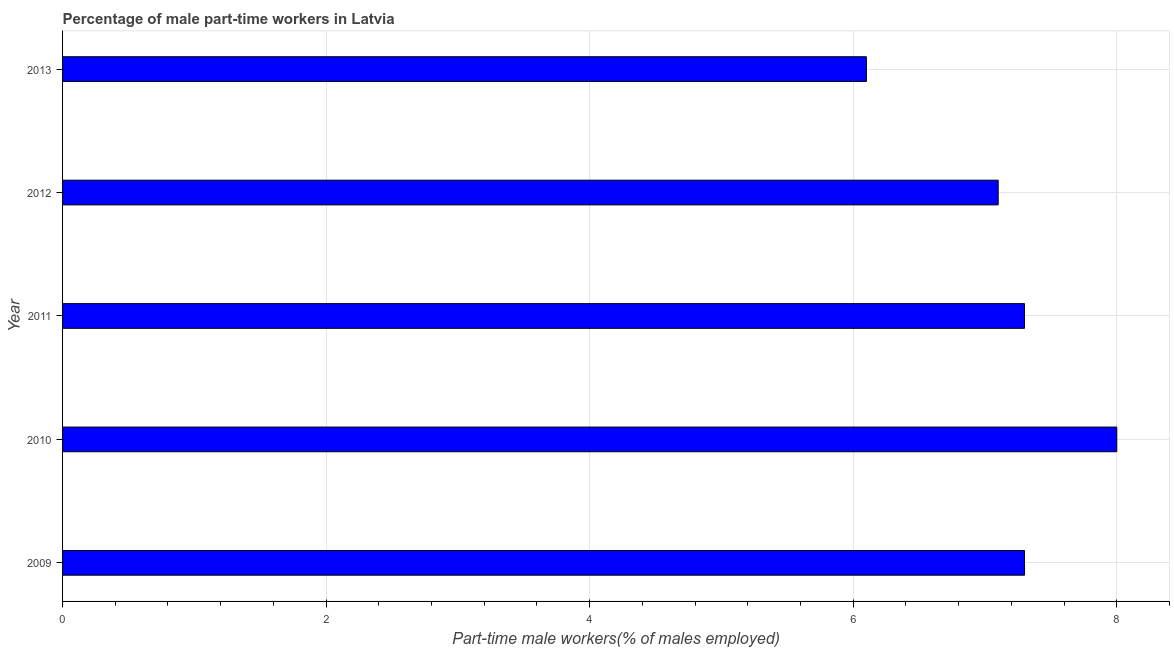What is the title of the graph?
Provide a short and direct response. Percentage of male part-time workers in Latvia. What is the label or title of the X-axis?
Your answer should be compact. Part-time male workers(% of males employed). What is the percentage of part-time male workers in 2012?
Offer a terse response. 7.1. Across all years, what is the minimum percentage of part-time male workers?
Offer a very short reply. 6.1. In which year was the percentage of part-time male workers maximum?
Your response must be concise. 2010. What is the sum of the percentage of part-time male workers?
Give a very brief answer. 35.8. What is the difference between the percentage of part-time male workers in 2009 and 2012?
Offer a very short reply. 0.2. What is the average percentage of part-time male workers per year?
Your response must be concise. 7.16. What is the median percentage of part-time male workers?
Offer a very short reply. 7.3. In how many years, is the percentage of part-time male workers greater than 6 %?
Provide a succinct answer. 5. Do a majority of the years between 2010 and 2012 (inclusive) have percentage of part-time male workers greater than 7.6 %?
Your answer should be very brief. No. Is the percentage of part-time male workers in 2009 less than that in 2013?
Provide a succinct answer. No. Is the sum of the percentage of part-time male workers in 2009 and 2013 greater than the maximum percentage of part-time male workers across all years?
Your response must be concise. Yes. What is the difference between the highest and the lowest percentage of part-time male workers?
Give a very brief answer. 1.9. Are all the bars in the graph horizontal?
Your response must be concise. Yes. What is the difference between two consecutive major ticks on the X-axis?
Give a very brief answer. 2. Are the values on the major ticks of X-axis written in scientific E-notation?
Offer a very short reply. No. What is the Part-time male workers(% of males employed) of 2009?
Make the answer very short. 7.3. What is the Part-time male workers(% of males employed) of 2010?
Offer a very short reply. 8. What is the Part-time male workers(% of males employed) of 2011?
Offer a very short reply. 7.3. What is the Part-time male workers(% of males employed) of 2012?
Make the answer very short. 7.1. What is the Part-time male workers(% of males employed) of 2013?
Your answer should be very brief. 6.1. What is the difference between the Part-time male workers(% of males employed) in 2009 and 2011?
Give a very brief answer. 0. What is the difference between the Part-time male workers(% of males employed) in 2010 and 2011?
Your answer should be very brief. 0.7. What is the difference between the Part-time male workers(% of males employed) in 2010 and 2012?
Keep it short and to the point. 0.9. What is the difference between the Part-time male workers(% of males employed) in 2011 and 2013?
Your answer should be compact. 1.2. What is the difference between the Part-time male workers(% of males employed) in 2012 and 2013?
Provide a short and direct response. 1. What is the ratio of the Part-time male workers(% of males employed) in 2009 to that in 2012?
Make the answer very short. 1.03. What is the ratio of the Part-time male workers(% of males employed) in 2009 to that in 2013?
Provide a succinct answer. 1.2. What is the ratio of the Part-time male workers(% of males employed) in 2010 to that in 2011?
Keep it short and to the point. 1.1. What is the ratio of the Part-time male workers(% of males employed) in 2010 to that in 2012?
Provide a succinct answer. 1.13. What is the ratio of the Part-time male workers(% of males employed) in 2010 to that in 2013?
Give a very brief answer. 1.31. What is the ratio of the Part-time male workers(% of males employed) in 2011 to that in 2012?
Keep it short and to the point. 1.03. What is the ratio of the Part-time male workers(% of males employed) in 2011 to that in 2013?
Make the answer very short. 1.2. What is the ratio of the Part-time male workers(% of males employed) in 2012 to that in 2013?
Give a very brief answer. 1.16. 